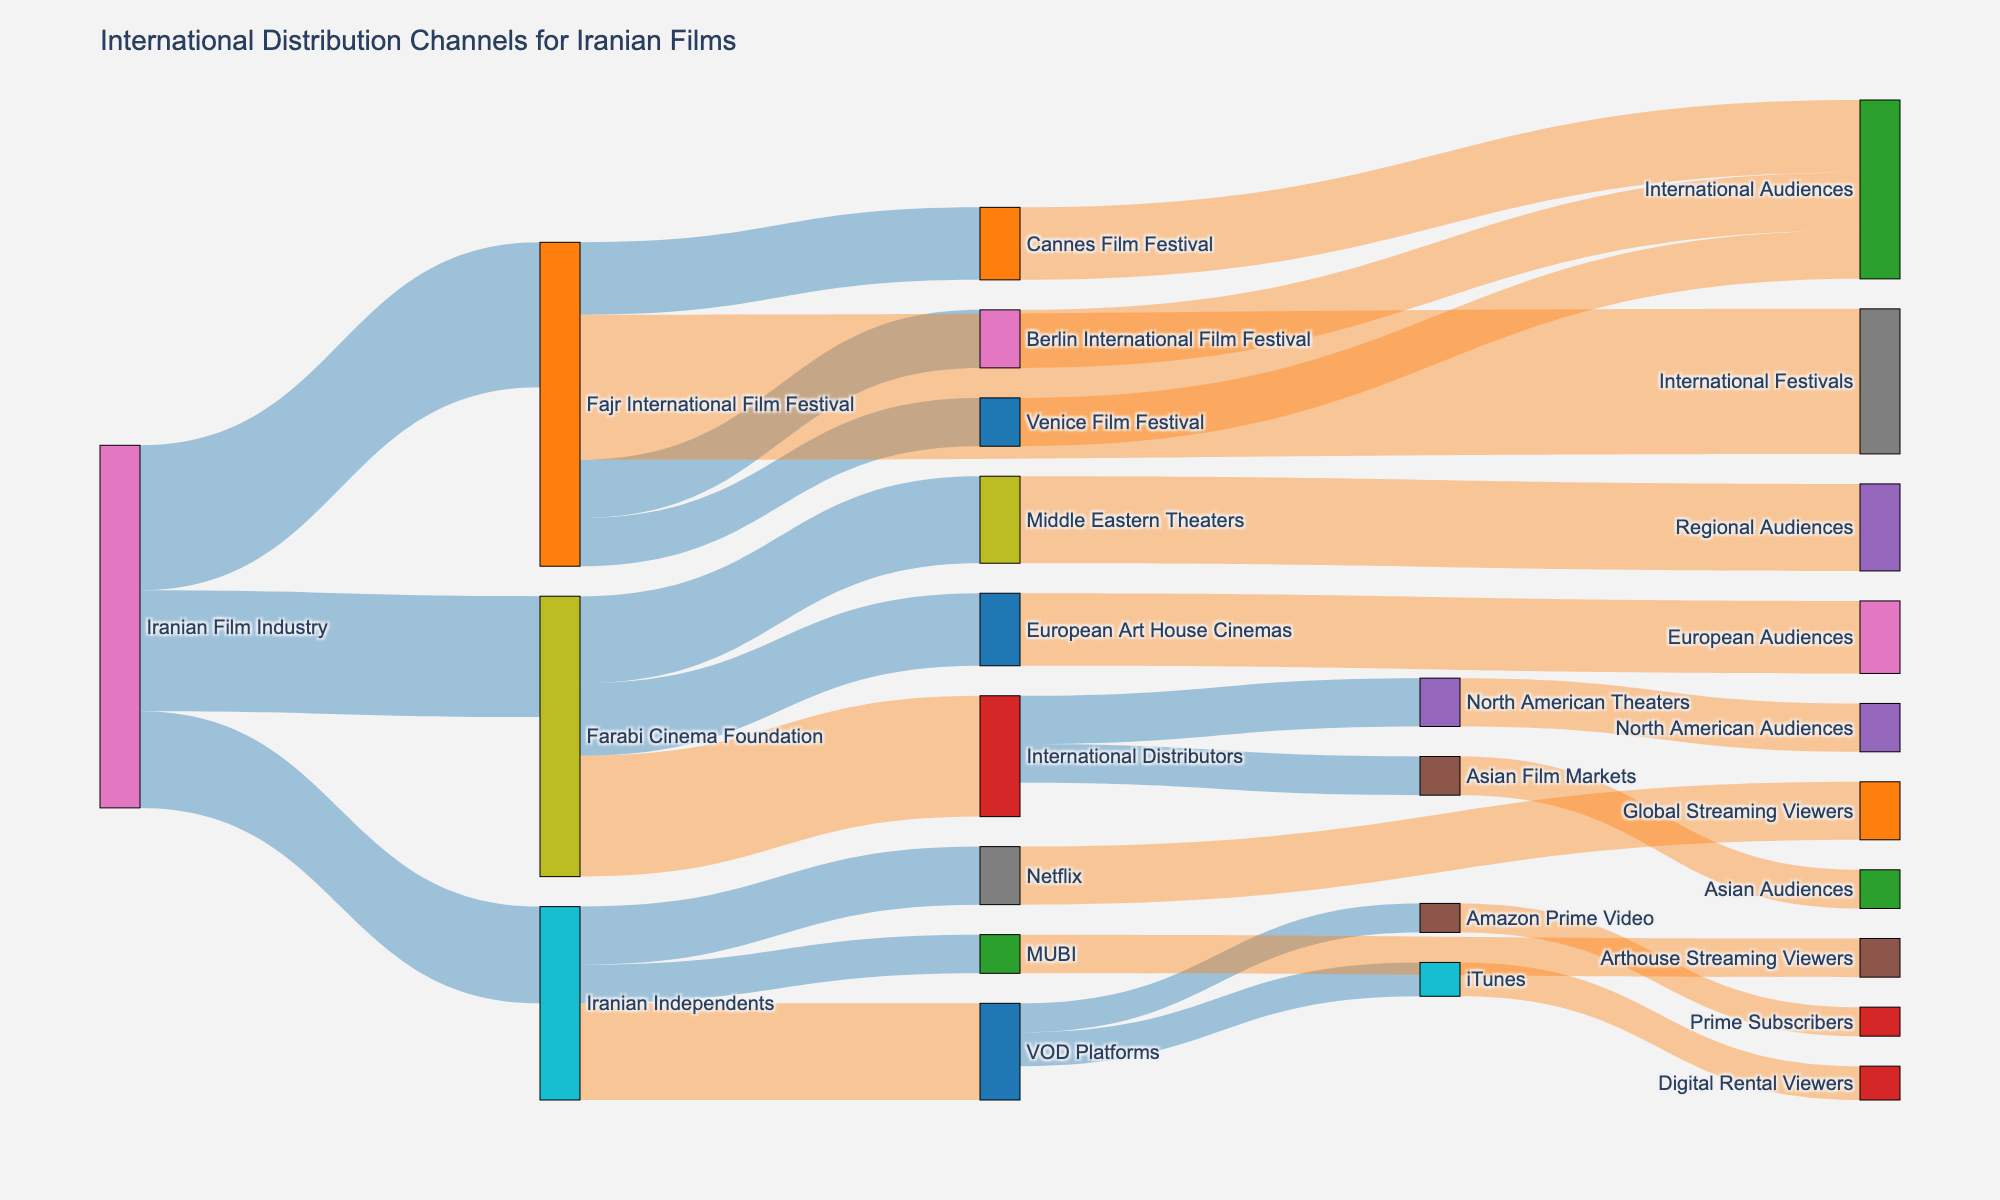What is the title of the Sankey diagram? The title is prominently displayed at the top of the figure.
Answer: International Distribution Channels for Iranian Films How many distribution channels are represented in the Sankey diagram originating from the Iranian Film Industry? The Iranian Film Industry leads to three intermediate nodes: Fajr International Film Festival, Farabi Cinema Foundation, and Iranian Independents.
Answer: 3 Which platform gets the highest value of films from the Iranian Independents? The link with the highest value from the Iranian Independents node leads to Netflix. The value is 12.
Answer: Netflix What is the total flow value from the Iranian Film Industry to international audiences via international festivals? The flow values from Fajr International Film Festival to Cannes Film Festival, Berlin International Film Festival, and Venice Film Festival sum up to 15 + 12 + 10.
Answer: 37 Compare the value of films distributed to European Art House Cinemas and North American Theaters. Which receives more, and by how much? The value for European Art House Cinemas is 15 and for North American Theaters is 10. The difference is 15 - 10.
Answer: European Art House Cinemas, by 5 What is the total flow value from the Farabi Cinema Foundation to both regional and European audiences? The values flowing from Farabi Cinema Foundation to Middle Eastern Theaters and European Art House Cinemas are 18 and 15, respectively. The sum is 18 + 15.
Answer: 33 How many different VOD platforms are used for distribution? From the node "VOD Platforms," there are three outgoing links to iTunes, Amazon Prime Video, and Netflix.
Answer: 3 Identify the platform that has the smallest flow value from VOD Platforms. Among the values from VOD Platforms (iTunes: 7, Netflix: 12, Amazon Prime Video: 6), Amazon Prime Video has the smallest value.
Answer: Amazon Prime Video 